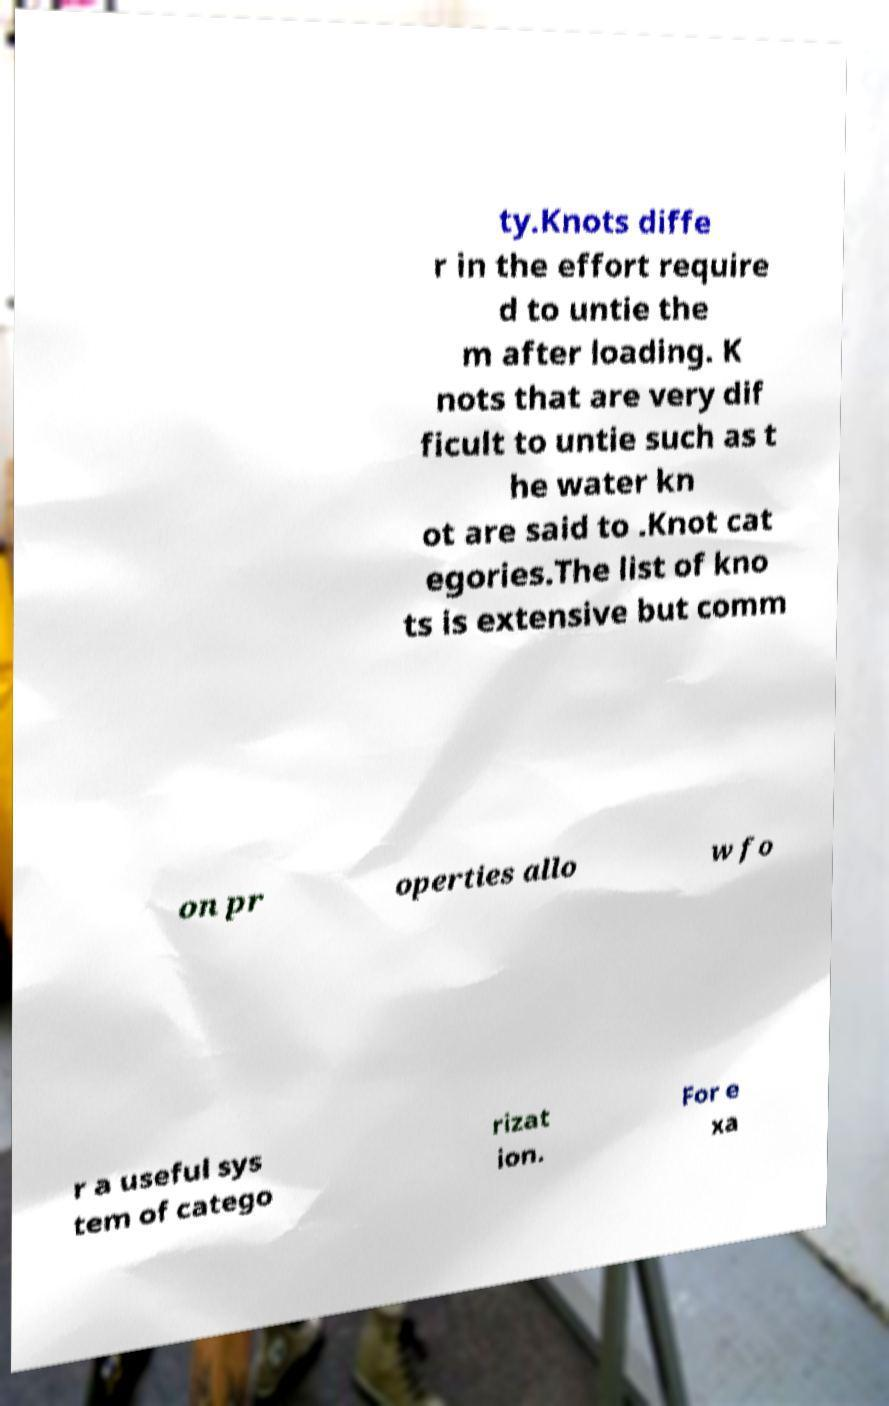I need the written content from this picture converted into text. Can you do that? ty.Knots diffe r in the effort require d to untie the m after loading. K nots that are very dif ficult to untie such as t he water kn ot are said to .Knot cat egories.The list of kno ts is extensive but comm on pr operties allo w fo r a useful sys tem of catego rizat ion. For e xa 